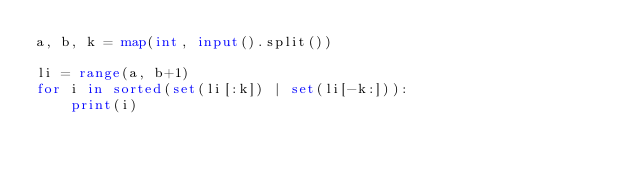<code> <loc_0><loc_0><loc_500><loc_500><_Python_>a, b, k = map(int, input().split())

li = range(a, b+1)
for i in sorted(set(li[:k]) | set(li[-k:])):
    print(i)</code> 